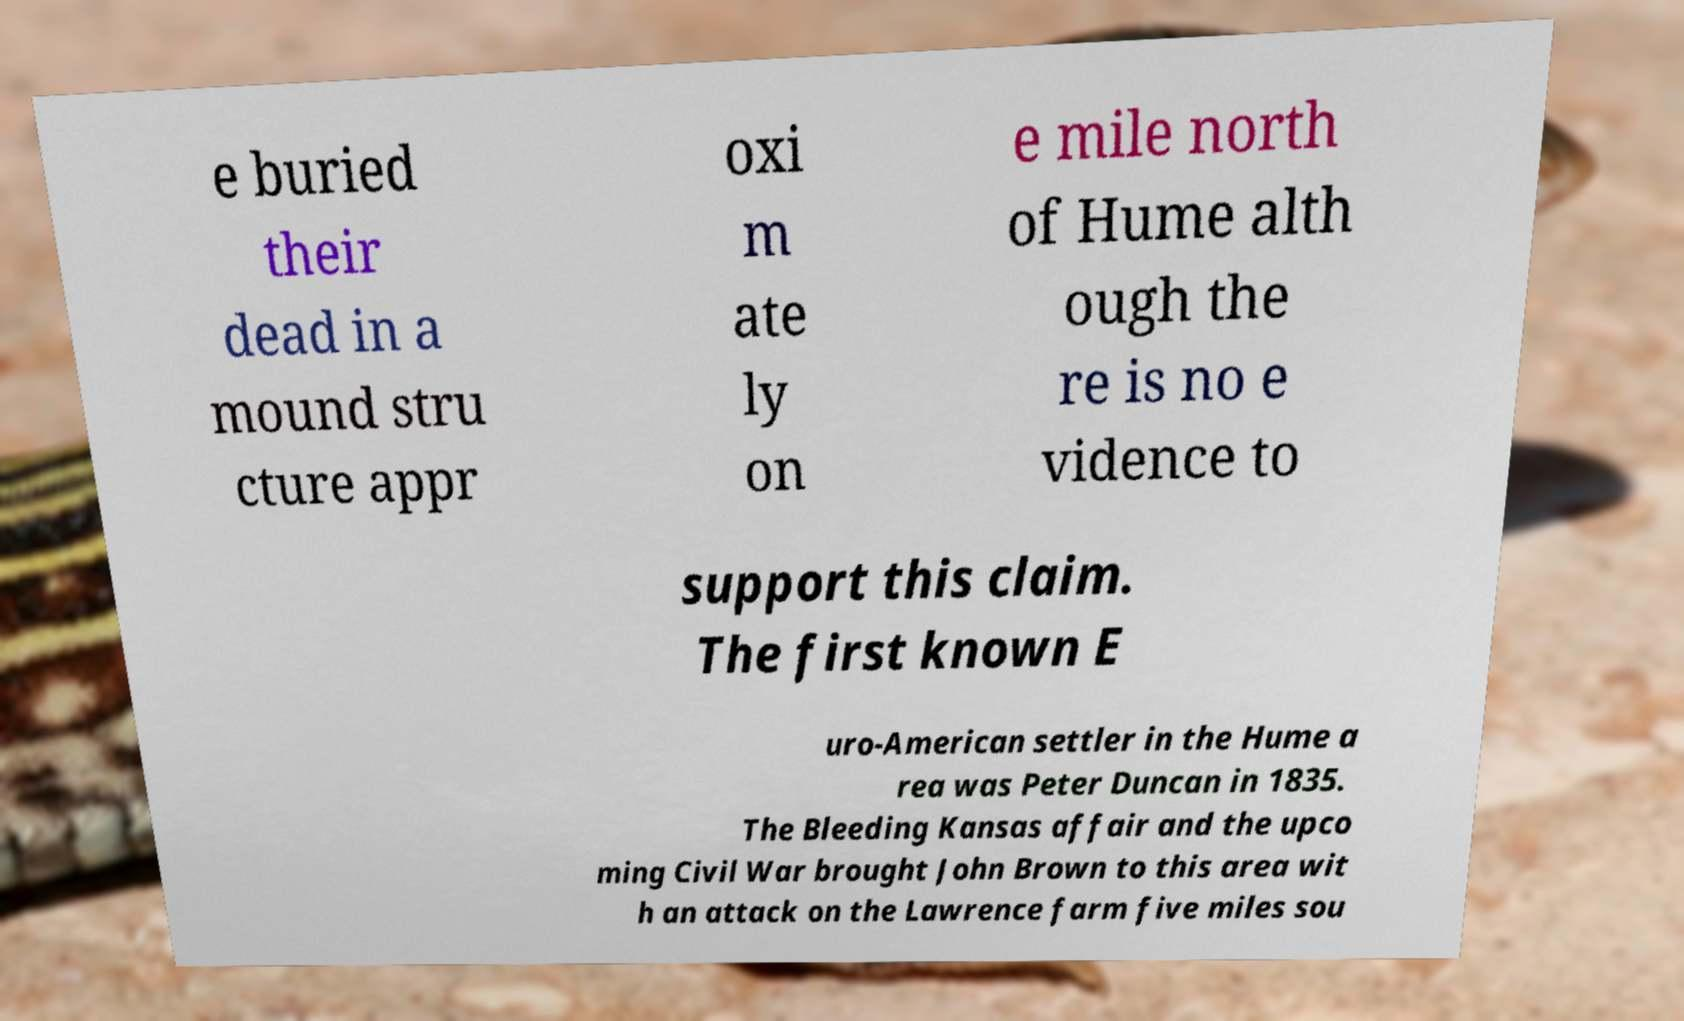Could you extract and type out the text from this image? e buried their dead in a mound stru cture appr oxi m ate ly on e mile north of Hume alth ough the re is no e vidence to support this claim. The first known E uro-American settler in the Hume a rea was Peter Duncan in 1835. The Bleeding Kansas affair and the upco ming Civil War brought John Brown to this area wit h an attack on the Lawrence farm five miles sou 